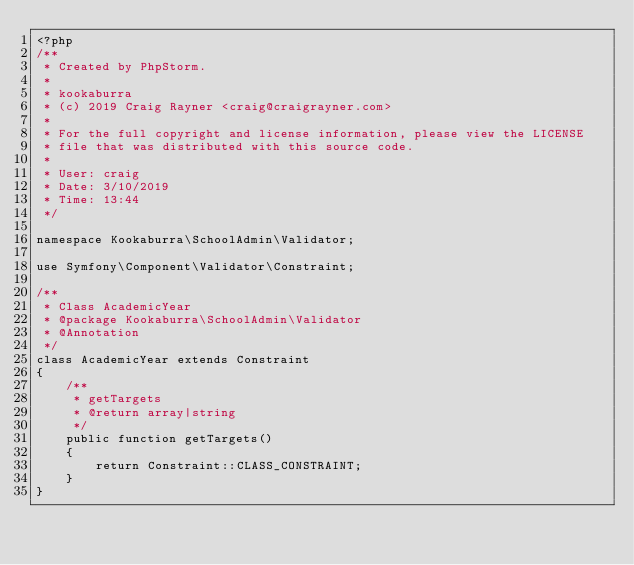Convert code to text. <code><loc_0><loc_0><loc_500><loc_500><_PHP_><?php
/**
 * Created by PhpStorm.
 *
 * kookaburra
 * (c) 2019 Craig Rayner <craig@craigrayner.com>
 *
 * For the full copyright and license information, please view the LICENSE
 * file that was distributed with this source code.
 *
 * User: craig
 * Date: 3/10/2019
 * Time: 13:44
 */

namespace Kookaburra\SchoolAdmin\Validator;

use Symfony\Component\Validator\Constraint;

/**
 * Class AcademicYear
 * @package Kookaburra\SchoolAdmin\Validator
 * @Annotation
 */
class AcademicYear extends Constraint
{
    /**
     * getTargets
     * @return array|string
     */
    public function getTargets()
    {
        return Constraint::CLASS_CONSTRAINT;
    }
}</code> 